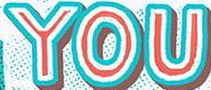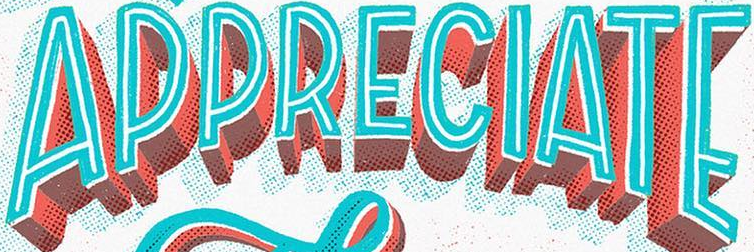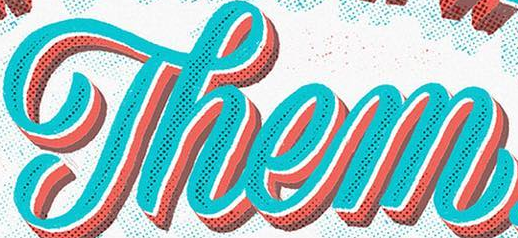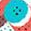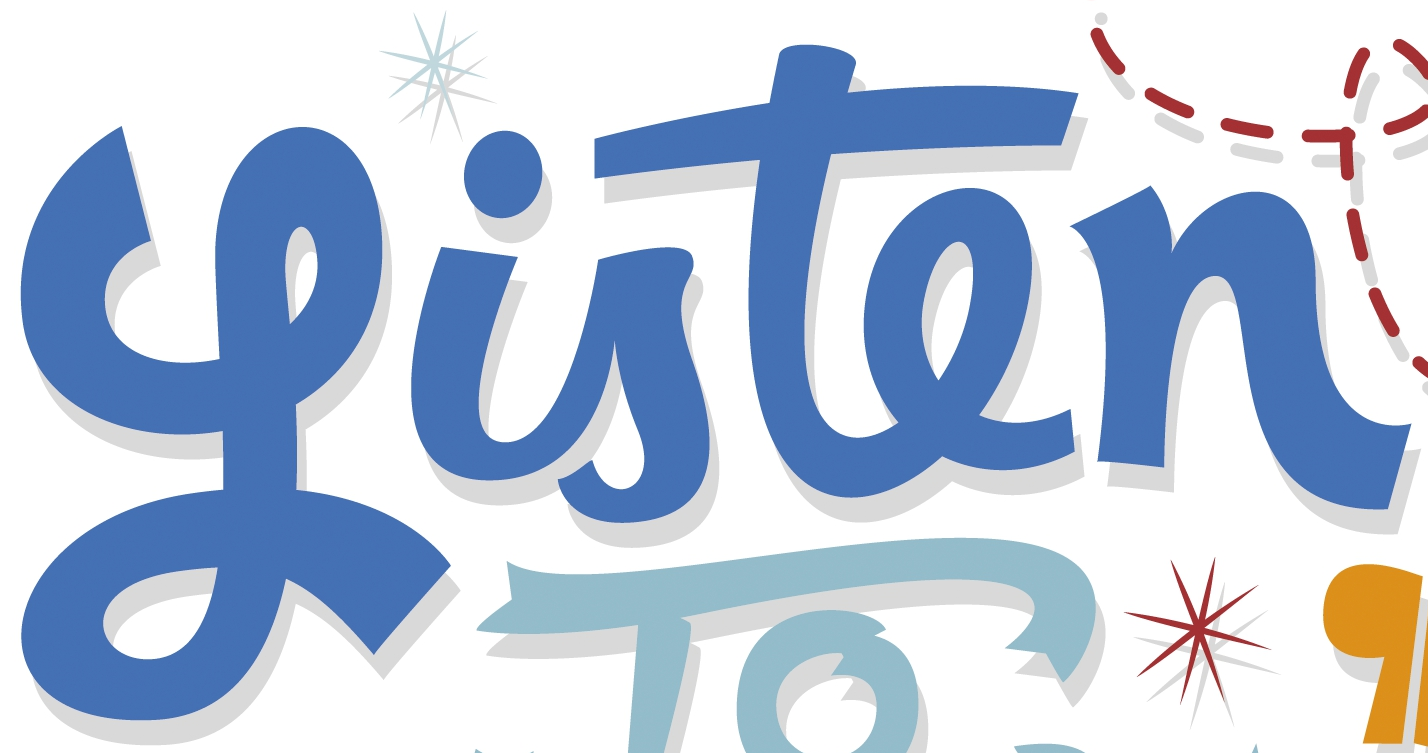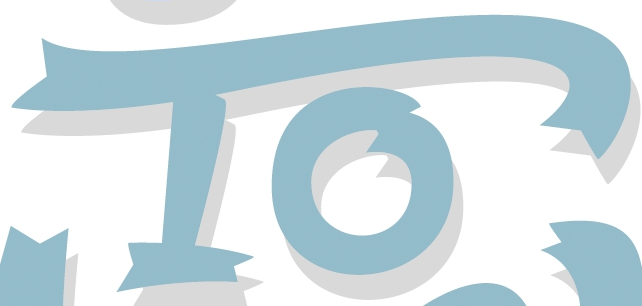What text is displayed in these images sequentially, separated by a semicolon? YOU; APPRECIATE; Them; .; Listen; To 